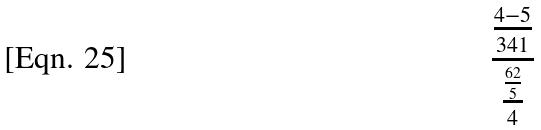Convert formula to latex. <formula><loc_0><loc_0><loc_500><loc_500>\frac { \frac { 4 - 5 } { 3 4 1 } } { \frac { \frac { 6 2 } { 5 } } { 4 } }</formula> 